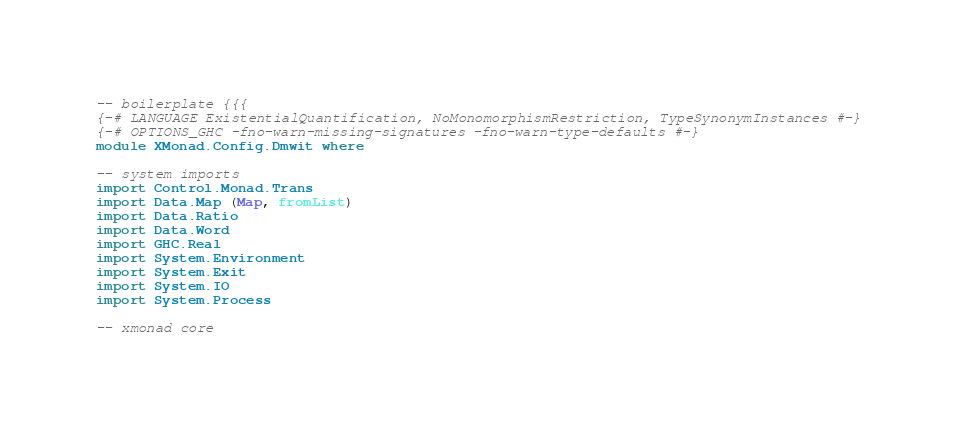Convert code to text. <code><loc_0><loc_0><loc_500><loc_500><_Haskell_>-- boilerplate {{{
{-# LANGUAGE ExistentialQuantification, NoMonomorphismRestriction, TypeSynonymInstances #-}
{-# OPTIONS_GHC -fno-warn-missing-signatures -fno-warn-type-defaults #-}
module XMonad.Config.Dmwit where

-- system imports
import Control.Monad.Trans
import Data.Map (Map, fromList)
import Data.Ratio
import Data.Word
import GHC.Real
import System.Environment
import System.Exit
import System.IO
import System.Process

-- xmonad core</code> 